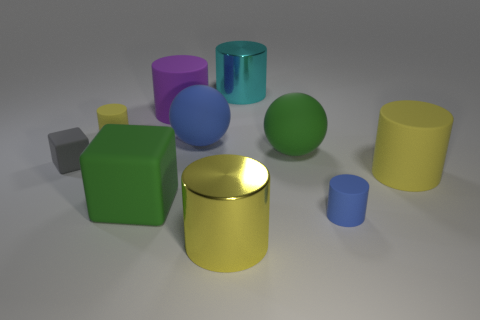What is the material of the large object that is the same color as the large matte block?
Offer a terse response. Rubber. Is the cylinder behind the large purple cylinder made of the same material as the purple object?
Ensure brevity in your answer.  No. There is a yellow object in front of the blue thing in front of the tiny matte thing that is to the left of the tiny yellow cylinder; what is its material?
Offer a very short reply. Metal. Are there any other things that are the same size as the green matte ball?
Your answer should be very brief. Yes. How many metal things are either big purple objects or big red blocks?
Your response must be concise. 0. Are there any big objects?
Offer a very short reply. Yes. The big rubber cylinder to the left of the yellow rubber object that is in front of the gray object is what color?
Keep it short and to the point. Purple. How many other objects are the same color as the large cube?
Ensure brevity in your answer.  1. How many things are either small shiny things or big matte balls that are right of the gray thing?
Your answer should be very brief. 2. The tiny rubber object that is right of the large purple thing is what color?
Your answer should be very brief. Blue. 